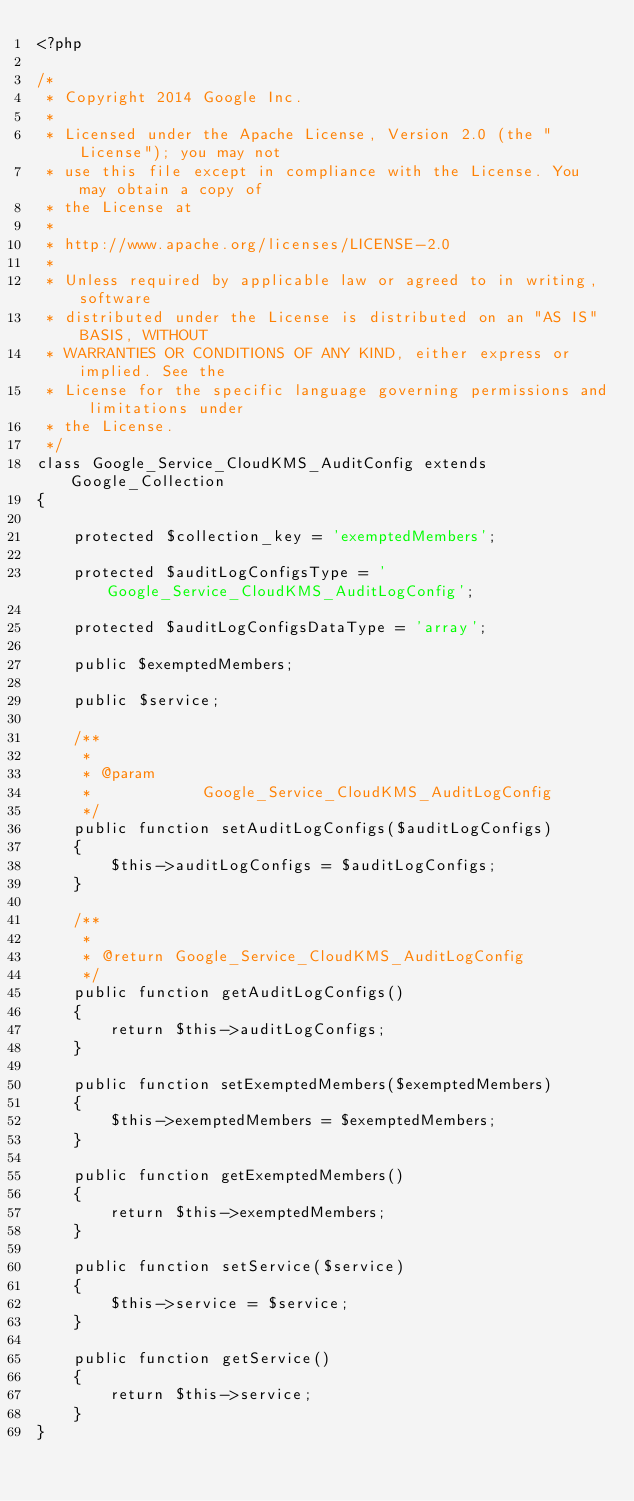<code> <loc_0><loc_0><loc_500><loc_500><_PHP_><?php

/*
 * Copyright 2014 Google Inc.
 *
 * Licensed under the Apache License, Version 2.0 (the "License"); you may not
 * use this file except in compliance with the License. You may obtain a copy of
 * the License at
 *
 * http://www.apache.org/licenses/LICENSE-2.0
 *
 * Unless required by applicable law or agreed to in writing, software
 * distributed under the License is distributed on an "AS IS" BASIS, WITHOUT
 * WARRANTIES OR CONDITIONS OF ANY KIND, either express or implied. See the
 * License for the specific language governing permissions and limitations under
 * the License.
 */
class Google_Service_CloudKMS_AuditConfig extends Google_Collection
{

    protected $collection_key = 'exemptedMembers';

    protected $auditLogConfigsType = 'Google_Service_CloudKMS_AuditLogConfig';

    protected $auditLogConfigsDataType = 'array';

    public $exemptedMembers;

    public $service;

    /**
     *
     * @param
     *            Google_Service_CloudKMS_AuditLogConfig
     */
    public function setAuditLogConfigs($auditLogConfigs)
    {
        $this->auditLogConfigs = $auditLogConfigs;
    }

    /**
     *
     * @return Google_Service_CloudKMS_AuditLogConfig
     */
    public function getAuditLogConfigs()
    {
        return $this->auditLogConfigs;
    }

    public function setExemptedMembers($exemptedMembers)
    {
        $this->exemptedMembers = $exemptedMembers;
    }

    public function getExemptedMembers()
    {
        return $this->exemptedMembers;
    }

    public function setService($service)
    {
        $this->service = $service;
    }

    public function getService()
    {
        return $this->service;
    }
}
</code> 